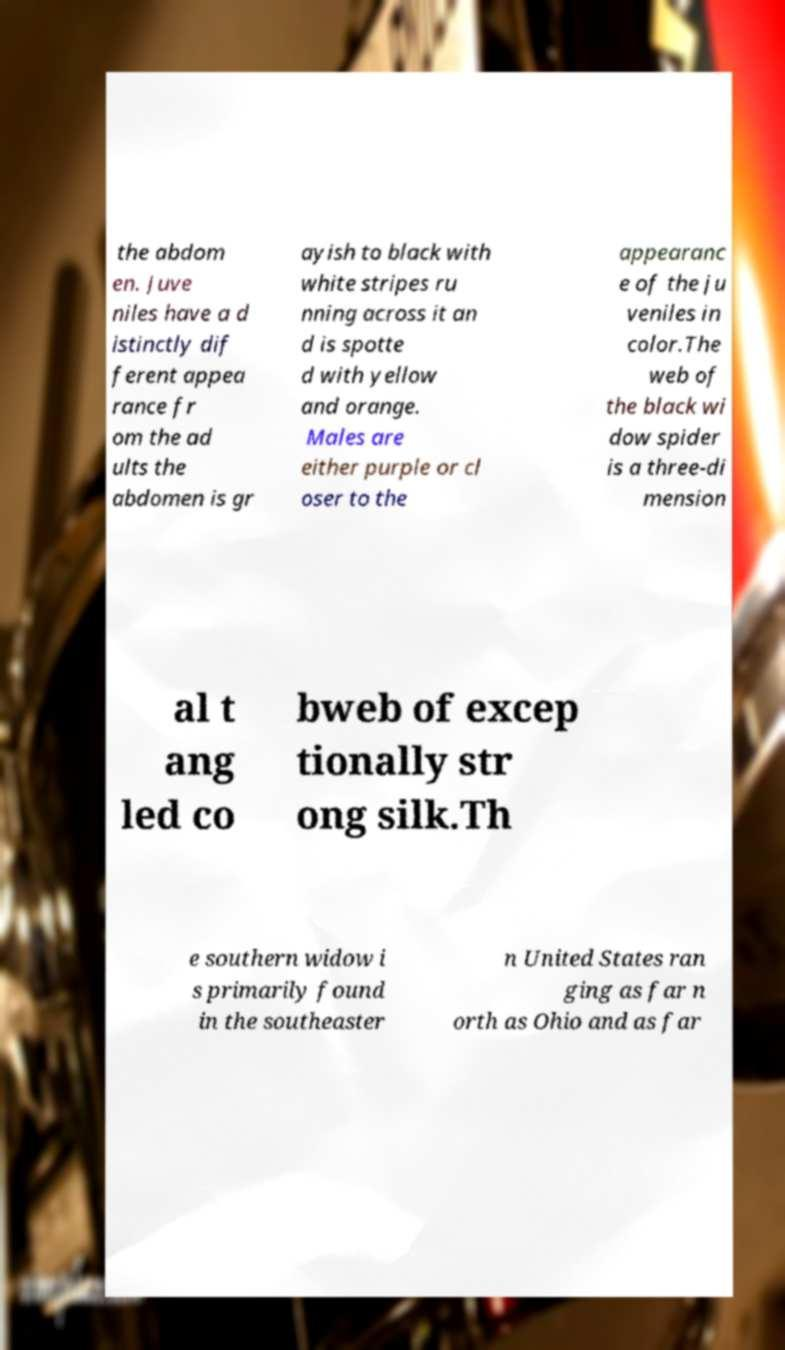Please identify and transcribe the text found in this image. the abdom en. Juve niles have a d istinctly dif ferent appea rance fr om the ad ults the abdomen is gr ayish to black with white stripes ru nning across it an d is spotte d with yellow and orange. Males are either purple or cl oser to the appearanc e of the ju veniles in color.The web of the black wi dow spider is a three-di mension al t ang led co bweb of excep tionally str ong silk.Th e southern widow i s primarily found in the southeaster n United States ran ging as far n orth as Ohio and as far 